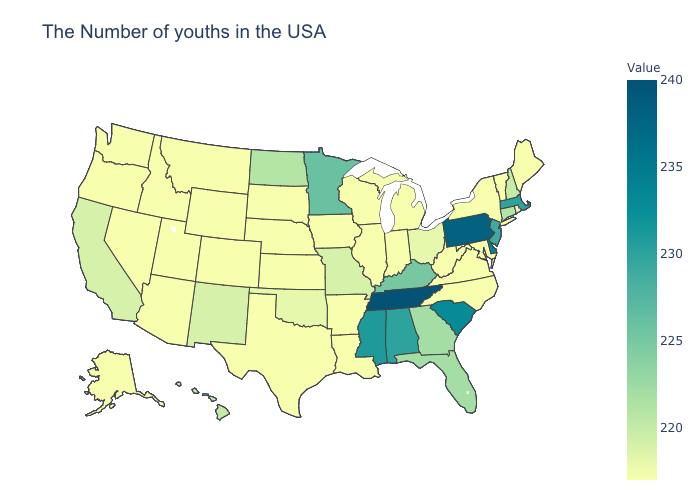Does Hawaii have the highest value in the USA?
Give a very brief answer. No. Does the map have missing data?
Quick response, please. No. Does Minnesota have the highest value in the MidWest?
Keep it brief. Yes. Which states have the lowest value in the MidWest?
Be succinct. Michigan, Indiana, Wisconsin, Illinois, Iowa, Kansas, Nebraska, South Dakota. Among the states that border North Dakota , which have the lowest value?
Concise answer only. South Dakota, Montana. Which states hav the highest value in the West?
Concise answer only. Hawaii. Does Massachusetts have the highest value in the USA?
Concise answer only. No. Does the map have missing data?
Write a very short answer. No. Does Tennessee have the highest value in the USA?
Be succinct. Yes. Does New Jersey have the lowest value in the Northeast?
Keep it brief. No. 